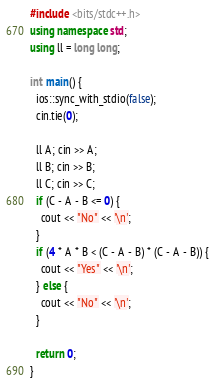Convert code to text. <code><loc_0><loc_0><loc_500><loc_500><_C++_>#include <bits/stdc++.h>
using namespace std;
using ll = long long;

int main() {
  ios::sync_with_stdio(false);
  cin.tie(0);

  ll A; cin >> A;
  ll B; cin >> B;
  ll C; cin >> C;
  if (C - A - B <= 0) {
    cout << "No" << '\n';
  }
  if (4 * A * B < (C - A - B) * (C - A - B)) {
    cout << "Yes" << '\n';
  } else {
    cout << "No" << '\n';
  }

  return 0;
}</code> 